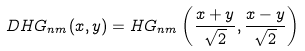Convert formula to latex. <formula><loc_0><loc_0><loc_500><loc_500>D H G _ { n m } ( x , y ) = H G _ { n m } \left ( \frac { x + y } { \sqrt { 2 } } , \frac { x - y } { \sqrt { 2 } } \right )</formula> 